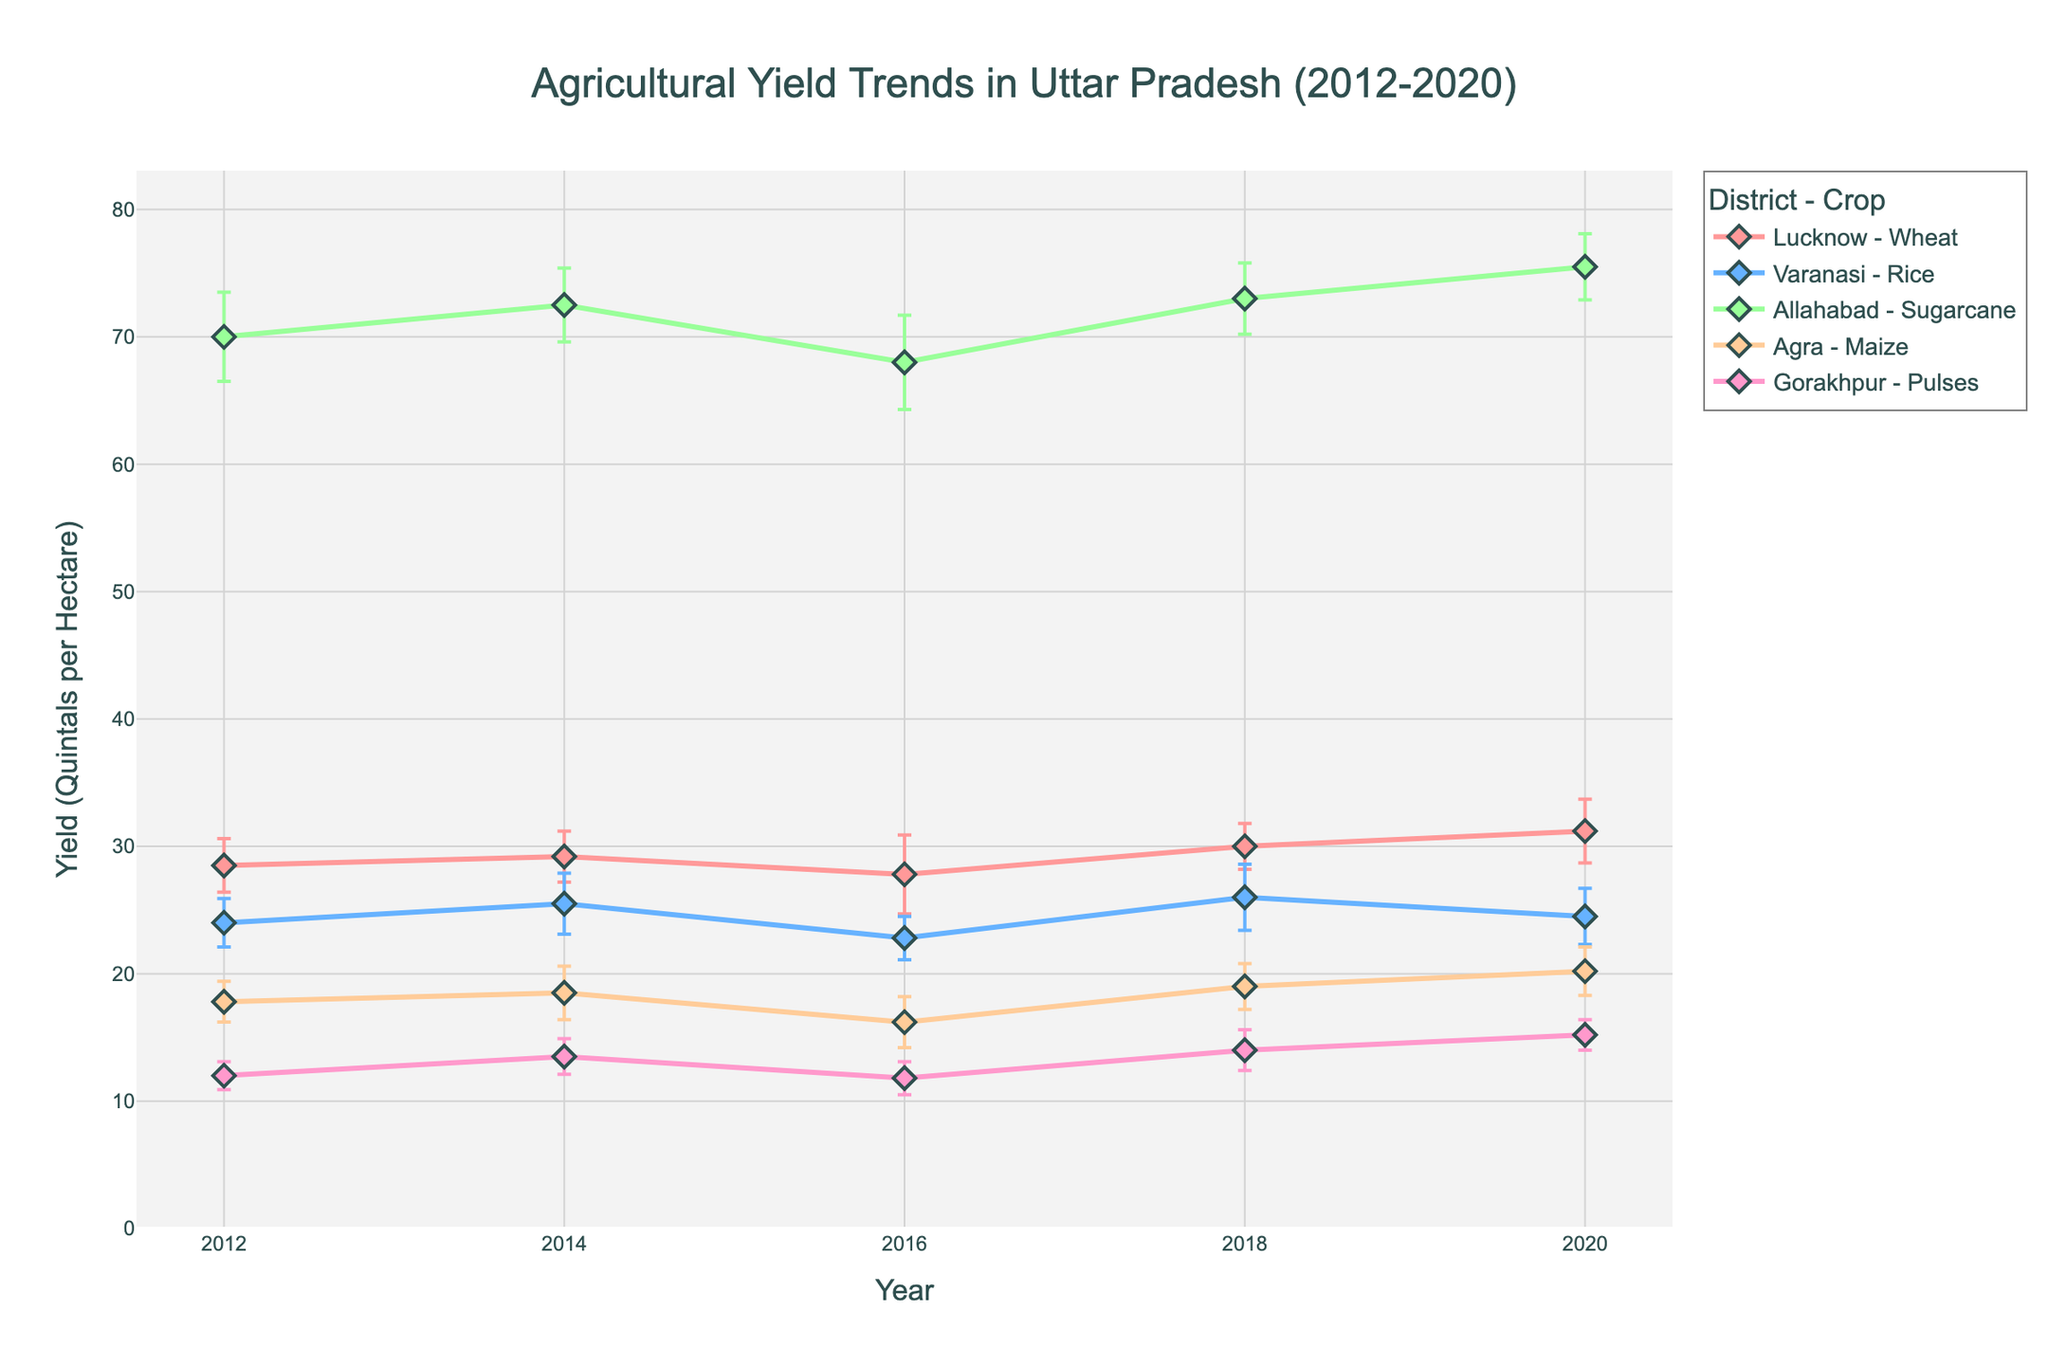What's the title of the figure? The title is usually displayed at the top of the chart. For this plot, the title is prominently shown.
Answer: Agricultural Yield Trends in Uttar Pradesh (2012-2020) How many districts are analyzed in this figure? Each district is represented by lines and markers with different colors. By counting the distinct line patterns and markers, we can see there are five districts.
Answer: Five Which district had the highest increase in yield from 2012 to 2020 for their respective crop? By comparing the starting yield in 2012 and the yield in 2020 for each district, Allahabad (Sugarcane) shows an increase from 70.0 to 75.5 quintals per hectare, which seems significant.
Answer: Allahabad What was the average yield of Pulses in Gorakhpur from 2012 to 2020? Adding the yields of Pulses for Gorakhpur from 2012 to 2020 (12.0, 13.5, 11.8, 14.0, 15.2) then dividing by the number of years (5) gives the average. So, (12.0 + 13.5 + 11.8 + 14.0 + 15.2)/5 = 13.3.
Answer: 13.3 Which crop had the most consistent yield in terms of lowest variability over the years for a district? By examining the standard deviations for each crop-district combination, Sugarcane in Allahabad shows the lowest variability with standard deviations (3.5, 2.9, 3.7, 2.8, 2.6), predominantly lower than other crops.
Answer: Sugarcane in Allahabad In which year did Varanasi report the highest yield for Rice? Tracking the yield of Rice for Varanasi across the years on the graph, the highest point occurs in 2018 with a yield of 26.0 quintals per hectare.
Answer: 2018 Which district's crop yield showed a decline between 2018 and 2020? By observing the downward trend in the plotted lines between these two years, it is evident that Varanasi (Rice) declined from 26.0 in 2018 to 24.5 in 2020.
Answer: Varanasi Compare the yield performance of Wheat in Lucknow and Maize in Agra in 2020. By looking at the figure for the year 2020, Wheat in Lucknow is 31.2 quintals per hectare while Maize in Agra is 20.2 quintals per hectare. Wheat in Lucknow has a higher yield.
Answer: Wheat in Lucknow What is the general trend in the yield of Wheat in Lucknow from 2012 to 2020? The yield points for Wheat in Lucknow show a generally increasing trend from 28.5 in 2012 to 31.2 in 2020 with some fluctuations.
Answer: Increasing Which crop had the highest standard deviation in any given year? By analyzing the error bars that represent the standard deviation, Wheat in Lucknow in 2016 shows the highest standard deviation of 3.1 quintals per hectare.
Answer: Wheat in Lucknow, 2016 